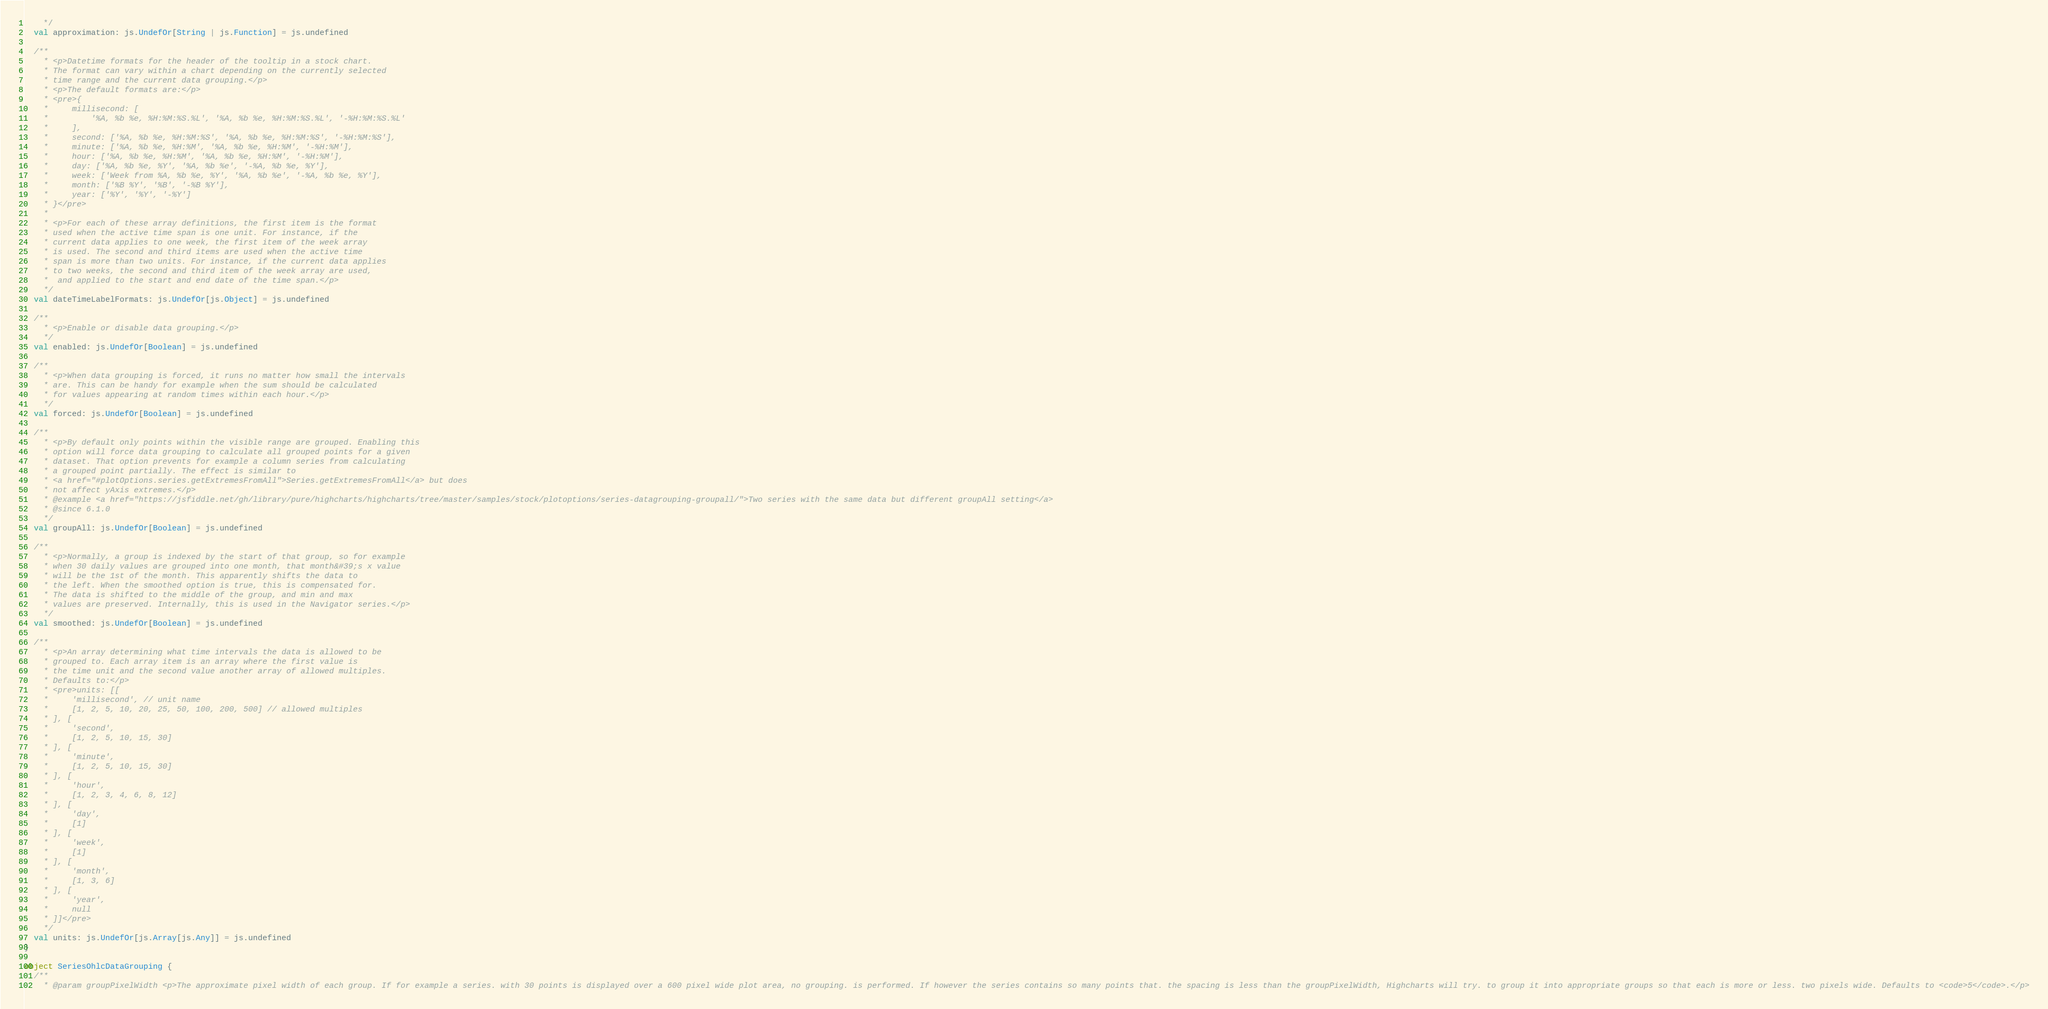Convert code to text. <code><loc_0><loc_0><loc_500><loc_500><_Scala_>    */
  val approximation: js.UndefOr[String | js.Function] = js.undefined

  /**
    * <p>Datetime formats for the header of the tooltip in a stock chart.
    * The format can vary within a chart depending on the currently selected
    * time range and the current data grouping.</p>
    * <p>The default formats are:</p>
    * <pre>{
    *     millisecond: [
    *         '%A, %b %e, %H:%M:%S.%L', '%A, %b %e, %H:%M:%S.%L', '-%H:%M:%S.%L'
    *     ],
    *     second: ['%A, %b %e, %H:%M:%S', '%A, %b %e, %H:%M:%S', '-%H:%M:%S'],
    *     minute: ['%A, %b %e, %H:%M', '%A, %b %e, %H:%M', '-%H:%M'],
    *     hour: ['%A, %b %e, %H:%M', '%A, %b %e, %H:%M', '-%H:%M'],
    *     day: ['%A, %b %e, %Y', '%A, %b %e', '-%A, %b %e, %Y'],
    *     week: ['Week from %A, %b %e, %Y', '%A, %b %e', '-%A, %b %e, %Y'],
    *     month: ['%B %Y', '%B', '-%B %Y'],
    *     year: ['%Y', '%Y', '-%Y']
    * }</pre>
    * 
    * <p>For each of these array definitions, the first item is the format
    * used when the active time span is one unit. For instance, if the
    * current data applies to one week, the first item of the week array
    * is used. The second and third items are used when the active time
    * span is more than two units. For instance, if the current data applies
    * to two weeks, the second and third item of the week array are used,
    *  and applied to the start and end date of the time span.</p>
    */
  val dateTimeLabelFormats: js.UndefOr[js.Object] = js.undefined

  /**
    * <p>Enable or disable data grouping.</p>
    */
  val enabled: js.UndefOr[Boolean] = js.undefined

  /**
    * <p>When data grouping is forced, it runs no matter how small the intervals
    * are. This can be handy for example when the sum should be calculated
    * for values appearing at random times within each hour.</p>
    */
  val forced: js.UndefOr[Boolean] = js.undefined

  /**
    * <p>By default only points within the visible range are grouped. Enabling this
    * option will force data grouping to calculate all grouped points for a given
    * dataset. That option prevents for example a column series from calculating
    * a grouped point partially. The effect is similar to
    * <a href="#plotOptions.series.getExtremesFromAll">Series.getExtremesFromAll</a> but does
    * not affect yAxis extremes.</p>
    * @example <a href="https://jsfiddle.net/gh/library/pure/highcharts/highcharts/tree/master/samples/stock/plotoptions/series-datagrouping-groupall/">Two series with the same data but different groupAll setting</a>
    * @since 6.1.0
    */
  val groupAll: js.UndefOr[Boolean] = js.undefined

  /**
    * <p>Normally, a group is indexed by the start of that group, so for example
    * when 30 daily values are grouped into one month, that month&#39;s x value
    * will be the 1st of the month. This apparently shifts the data to
    * the left. When the smoothed option is true, this is compensated for.
    * The data is shifted to the middle of the group, and min and max
    * values are preserved. Internally, this is used in the Navigator series.</p>
    */
  val smoothed: js.UndefOr[Boolean] = js.undefined

  /**
    * <p>An array determining what time intervals the data is allowed to be
    * grouped to. Each array item is an array where the first value is
    * the time unit and the second value another array of allowed multiples.
    * Defaults to:</p>
    * <pre>units: [[
    *     'millisecond', // unit name
    *     [1, 2, 5, 10, 20, 25, 50, 100, 200, 500] // allowed multiples
    * ], [
    *     'second',
    *     [1, 2, 5, 10, 15, 30]
    * ], [
    *     'minute',
    *     [1, 2, 5, 10, 15, 30]
    * ], [
    *     'hour',
    *     [1, 2, 3, 4, 6, 8, 12]
    * ], [
    *     'day',
    *     [1]
    * ], [
    *     'week',
    *     [1]
    * ], [
    *     'month',
    *     [1, 3, 6]
    * ], [
    *     'year',
    *     null
    * ]]</pre>
    */
  val units: js.UndefOr[js.Array[js.Any]] = js.undefined
}

object SeriesOhlcDataGrouping {
  /**
    * @param groupPixelWidth <p>The approximate pixel width of each group. If for example a series. with 30 points is displayed over a 600 pixel wide plot area, no grouping. is performed. If however the series contains so many points that. the spacing is less than the groupPixelWidth, Highcharts will try. to group it into appropriate groups so that each is more or less. two pixels wide. Defaults to <code>5</code>.</p></code> 